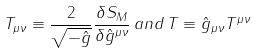<formula> <loc_0><loc_0><loc_500><loc_500>T _ { \mu \nu } \equiv \frac { 2 } { \sqrt { - \hat { g } } } \frac { \delta S _ { M } } { \delta \hat { g } ^ { \mu \nu } } \, a n d \, T \equiv \hat { g } _ { \mu \nu } T ^ { \mu \nu }</formula> 